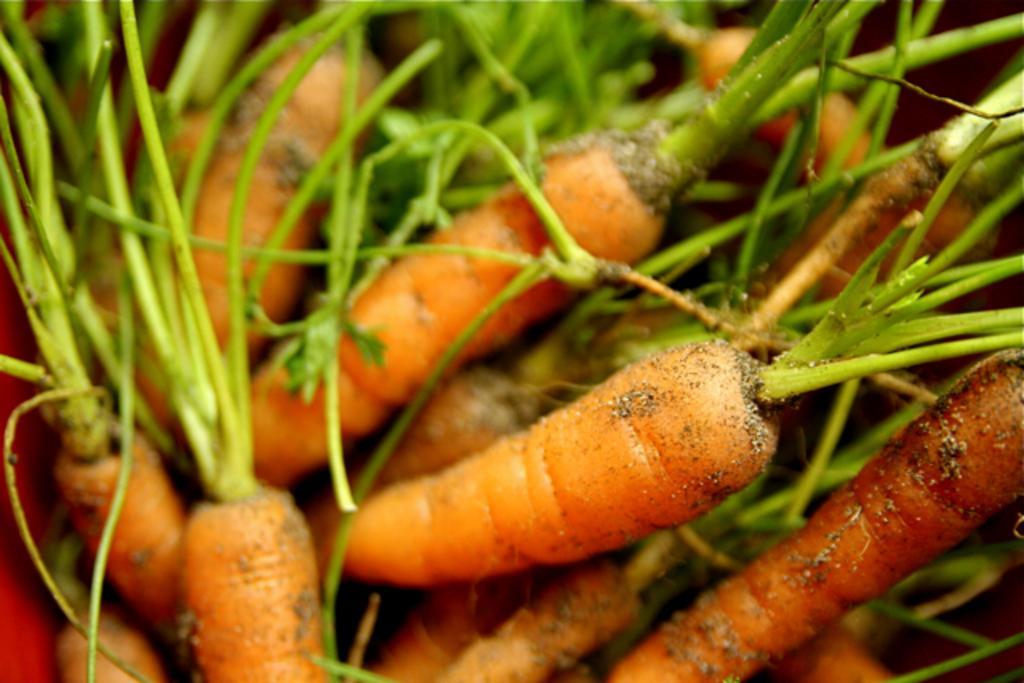How would you summarize this image in a sentence or two? In this image I can see carrot plants on the ground. This image is taken may be during a day. 